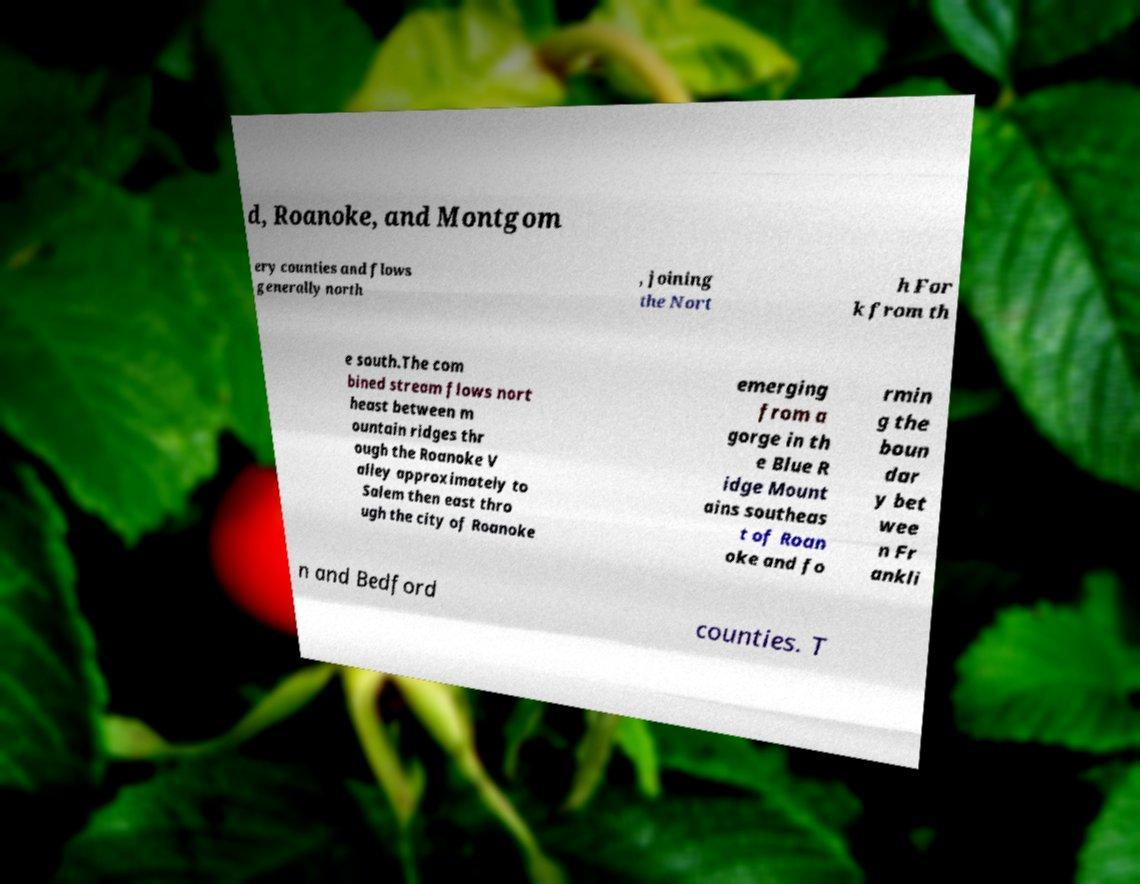What messages or text are displayed in this image? I need them in a readable, typed format. d, Roanoke, and Montgom ery counties and flows generally north , joining the Nort h For k from th e south.The com bined stream flows nort heast between m ountain ridges thr ough the Roanoke V alley approximately to Salem then east thro ugh the city of Roanoke emerging from a gorge in th e Blue R idge Mount ains southeas t of Roan oke and fo rmin g the boun dar y bet wee n Fr ankli n and Bedford counties. T 